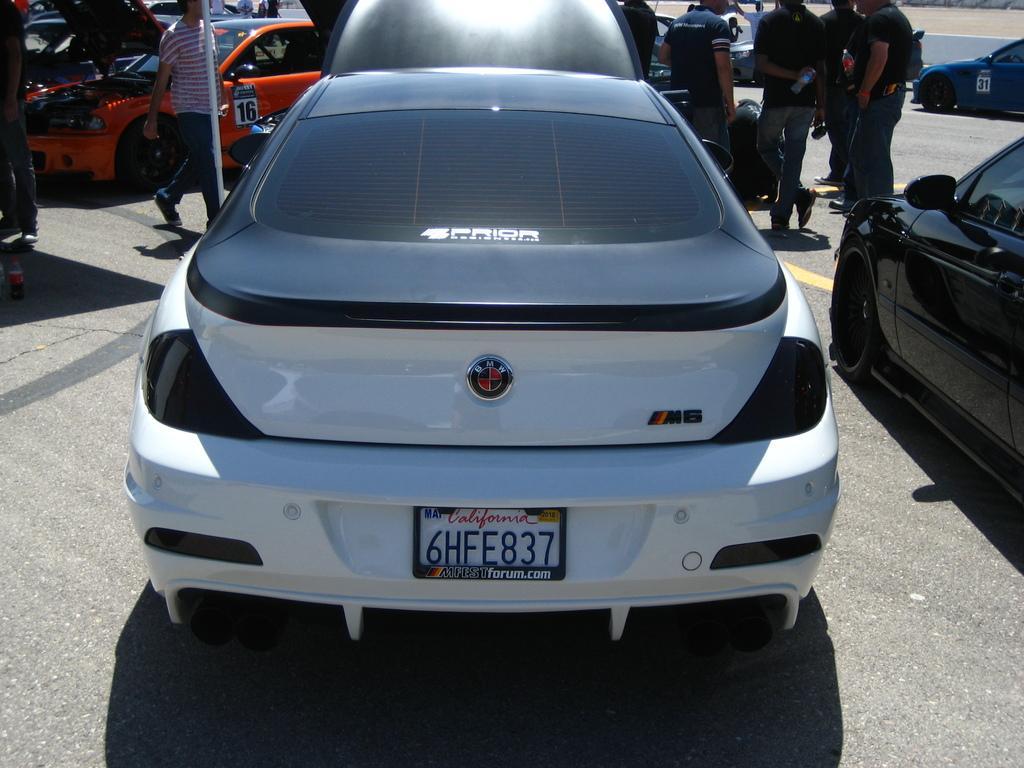How would you summarize this image in a sentence or two? These are the cars, which are parked. I can see a person walking. This looks like a pole. I can see a group of people standing. This looks like a bottle, which is placed on the road. 